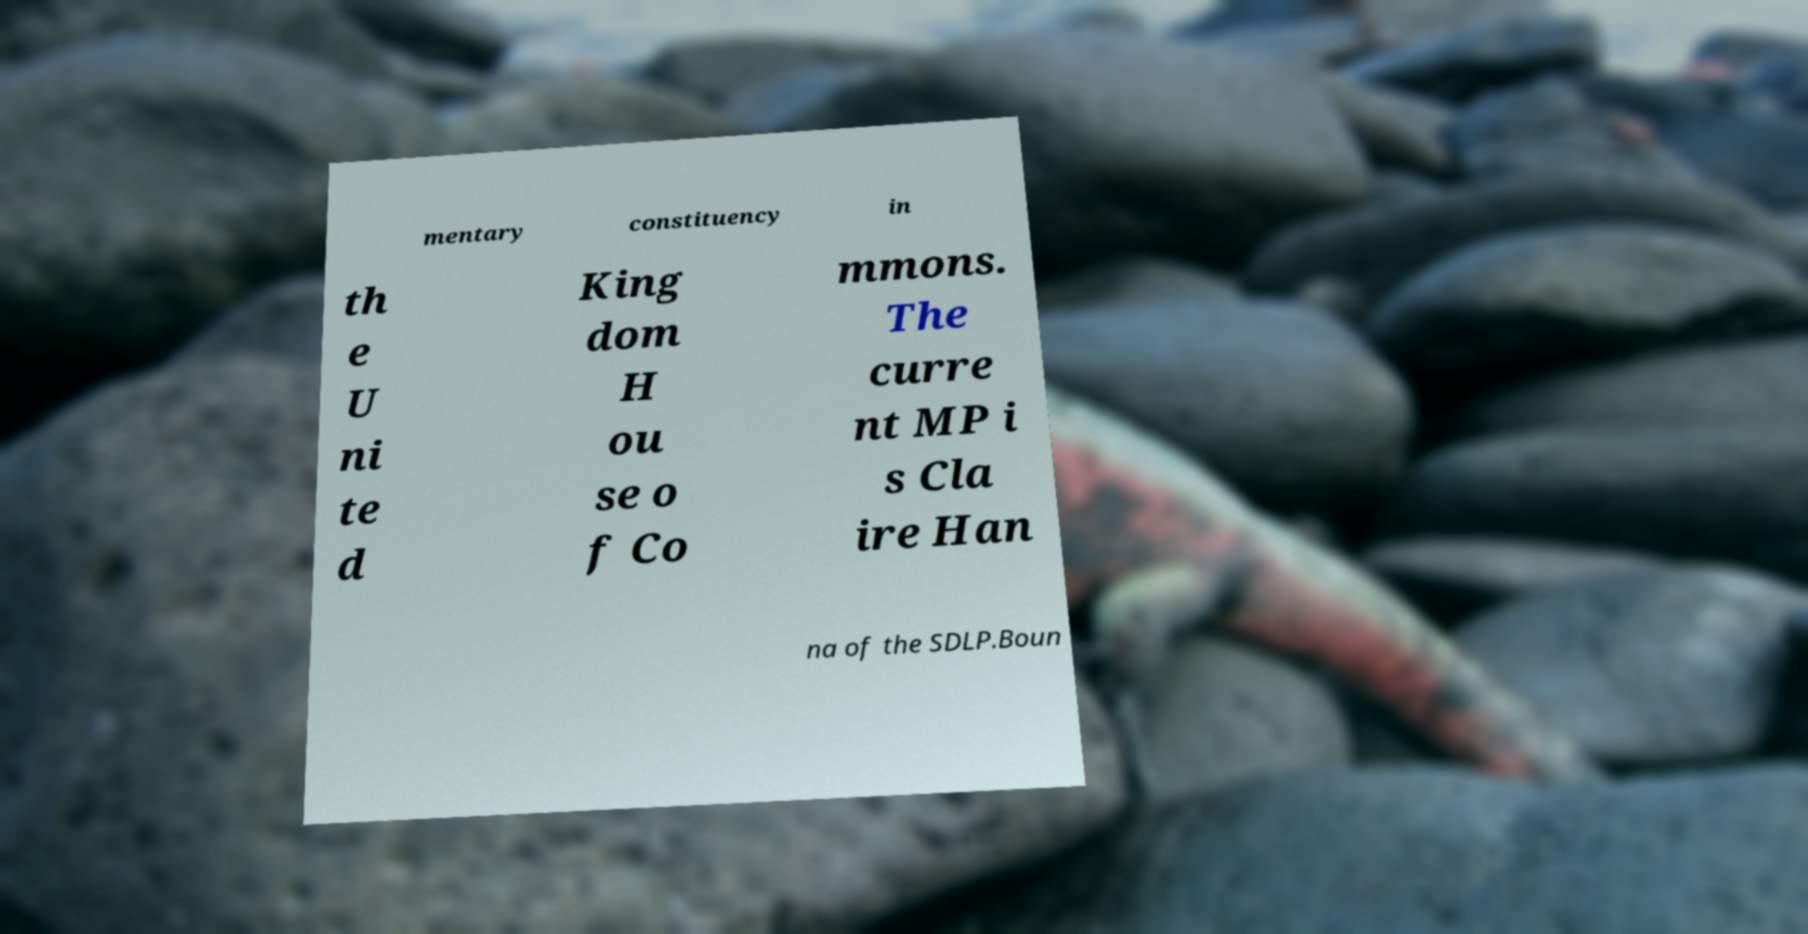There's text embedded in this image that I need extracted. Can you transcribe it verbatim? mentary constituency in th e U ni te d King dom H ou se o f Co mmons. The curre nt MP i s Cla ire Han na of the SDLP.Boun 